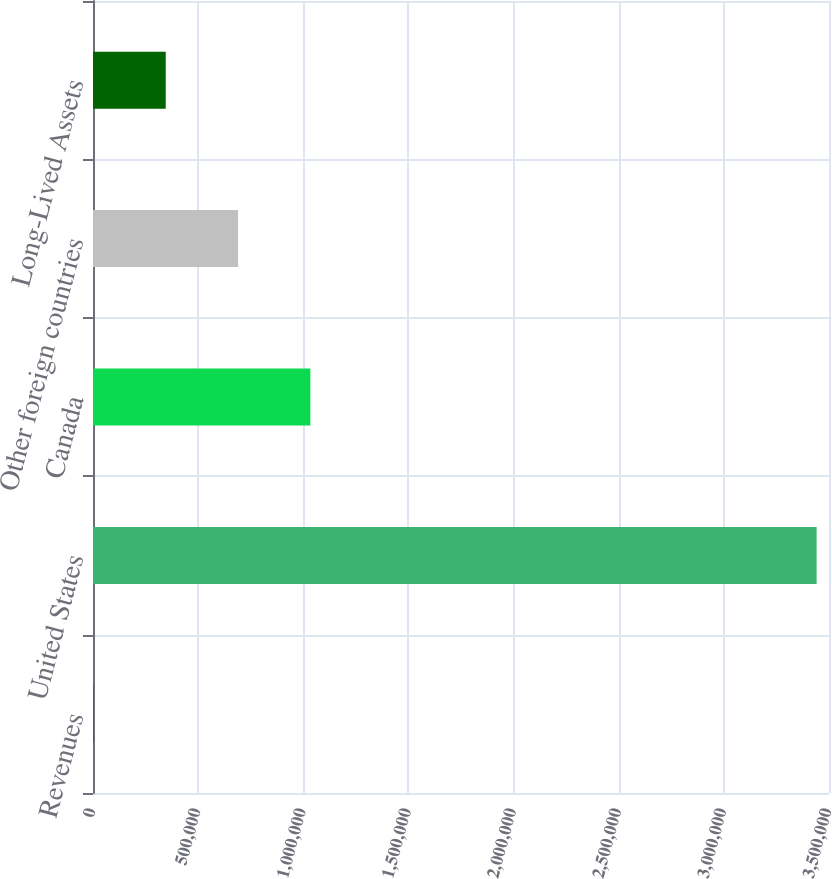Convert chart. <chart><loc_0><loc_0><loc_500><loc_500><bar_chart><fcel>Revenues<fcel>United States<fcel>Canada<fcel>Other foreign countries<fcel>Long-Lived Assets<nl><fcel>2015<fcel>3.44114e+06<fcel>1.03375e+06<fcel>689840<fcel>345928<nl></chart> 